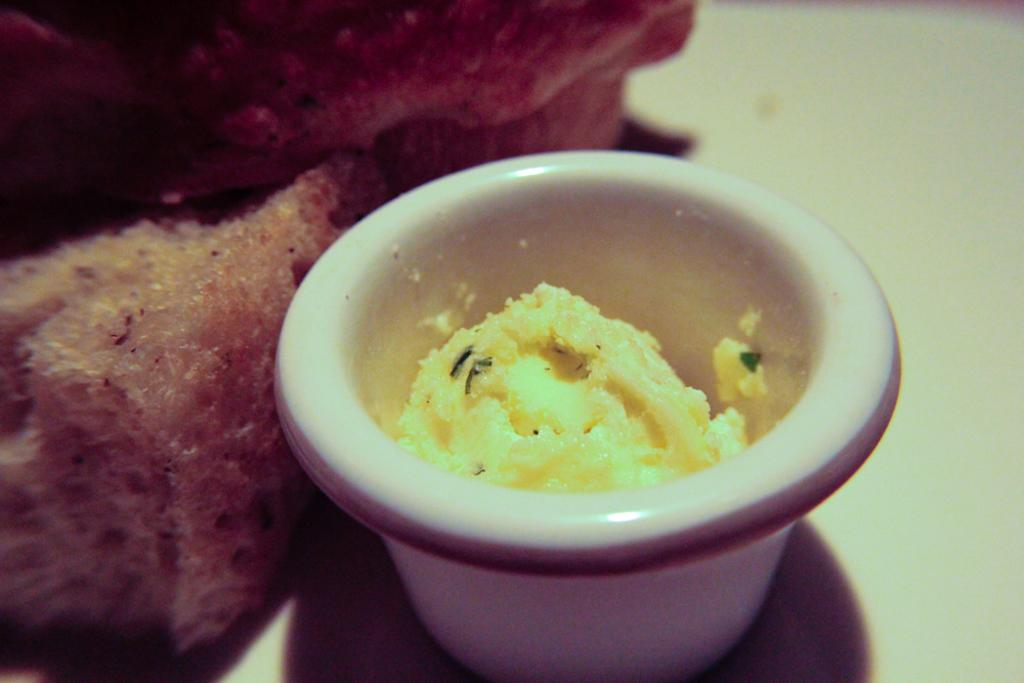What is present on the plate in the image? There are food items on the plate in the image. What else can be seen in the image besides the plate? There is a bowl in the image. What is inside the bowl? There is a food item in the bowl. What type of root can be seen growing from the plate in the image? There is no root present in the image; it features a plate with food items and a bowl with a food item. 